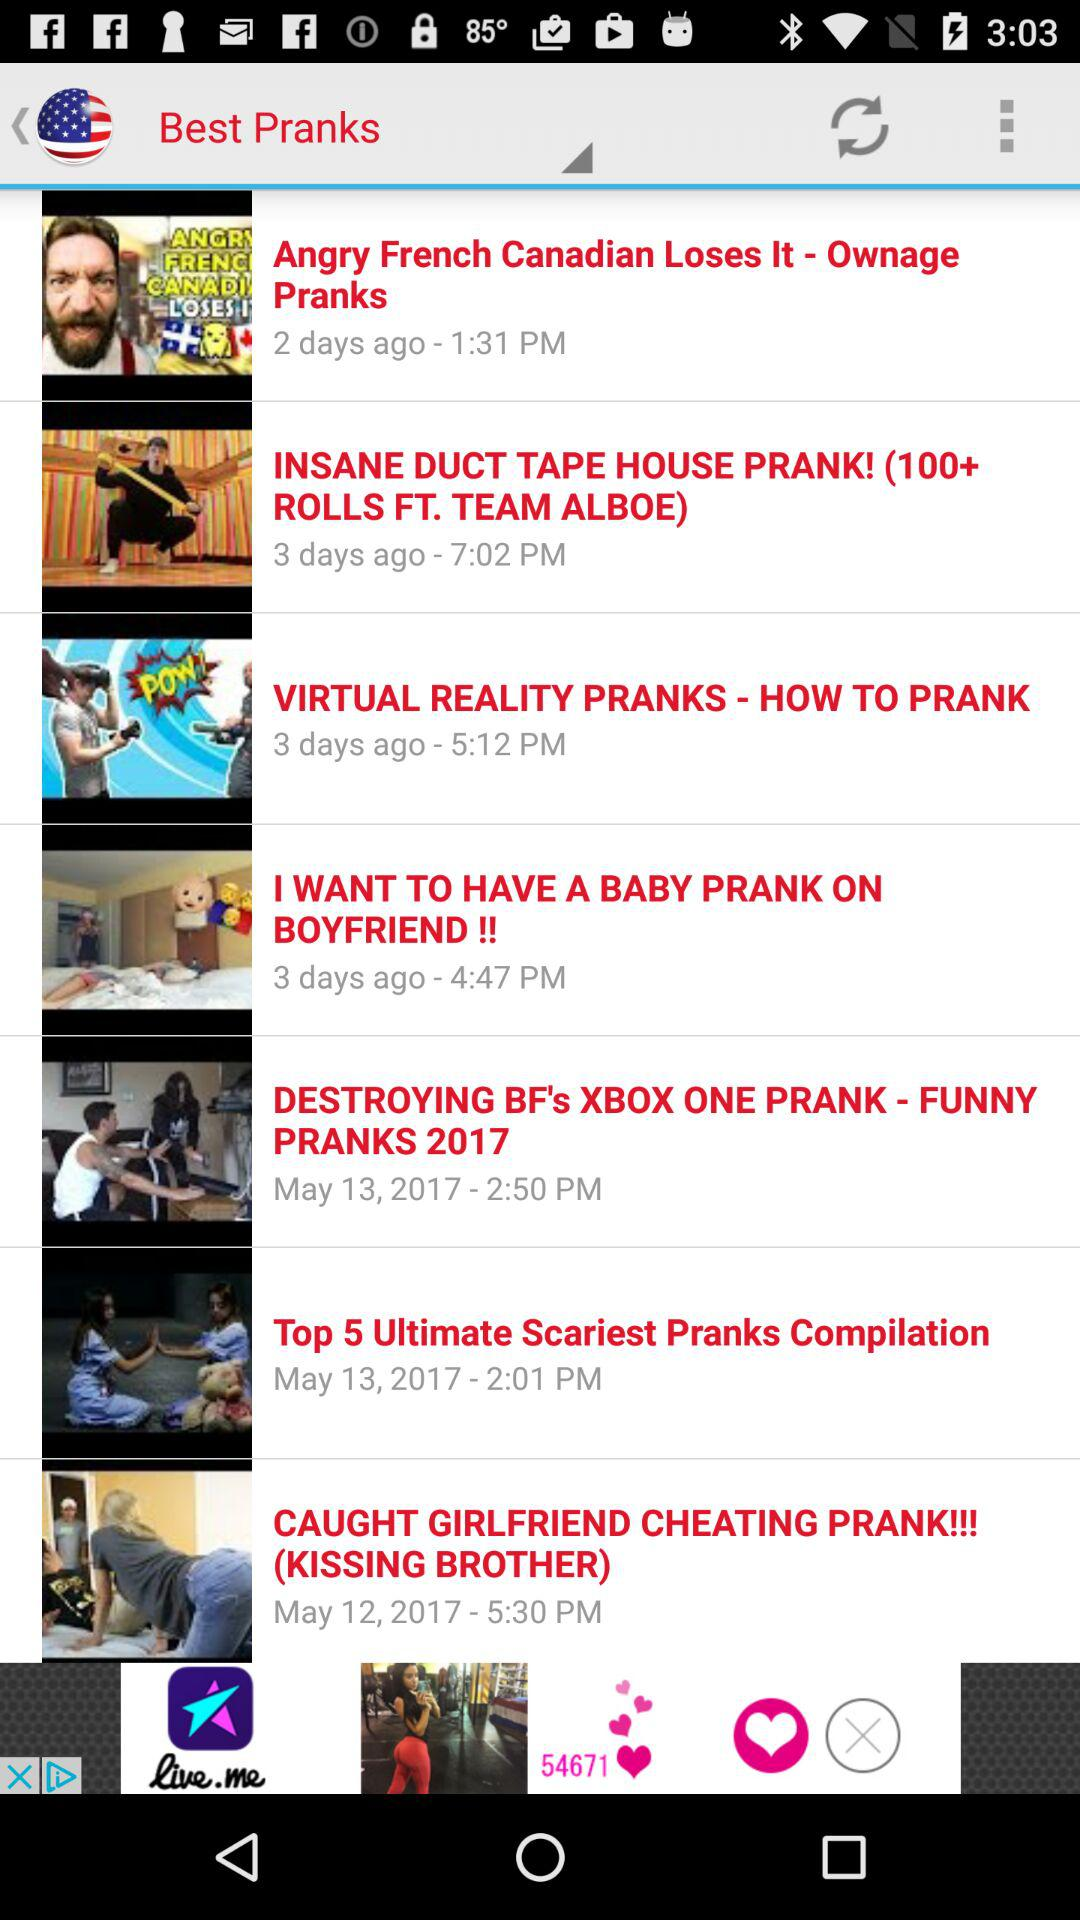When was the video "I WANT TO HAVE A BABY PRANK ON BOYFRIEND!!" posted? The video was posted 3 days ago at 4:47 PM. 